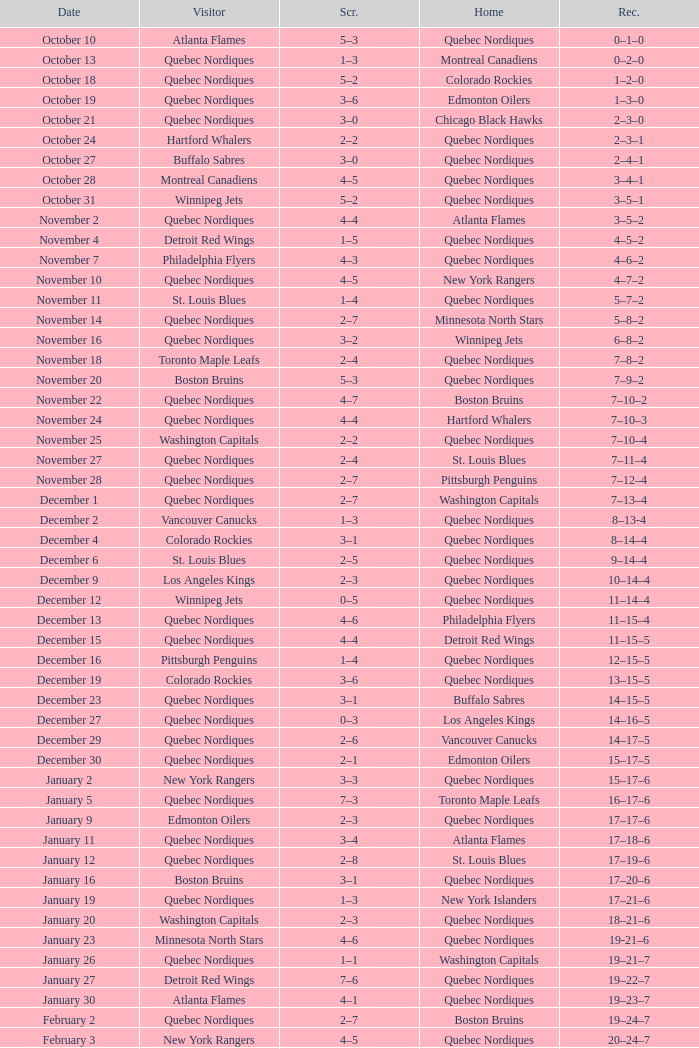Which Home has a Date of april 1? Quebec Nordiques. 